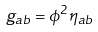Convert formula to latex. <formula><loc_0><loc_0><loc_500><loc_500>g _ { a b } = \phi ^ { 2 } \eta _ { a b }</formula> 